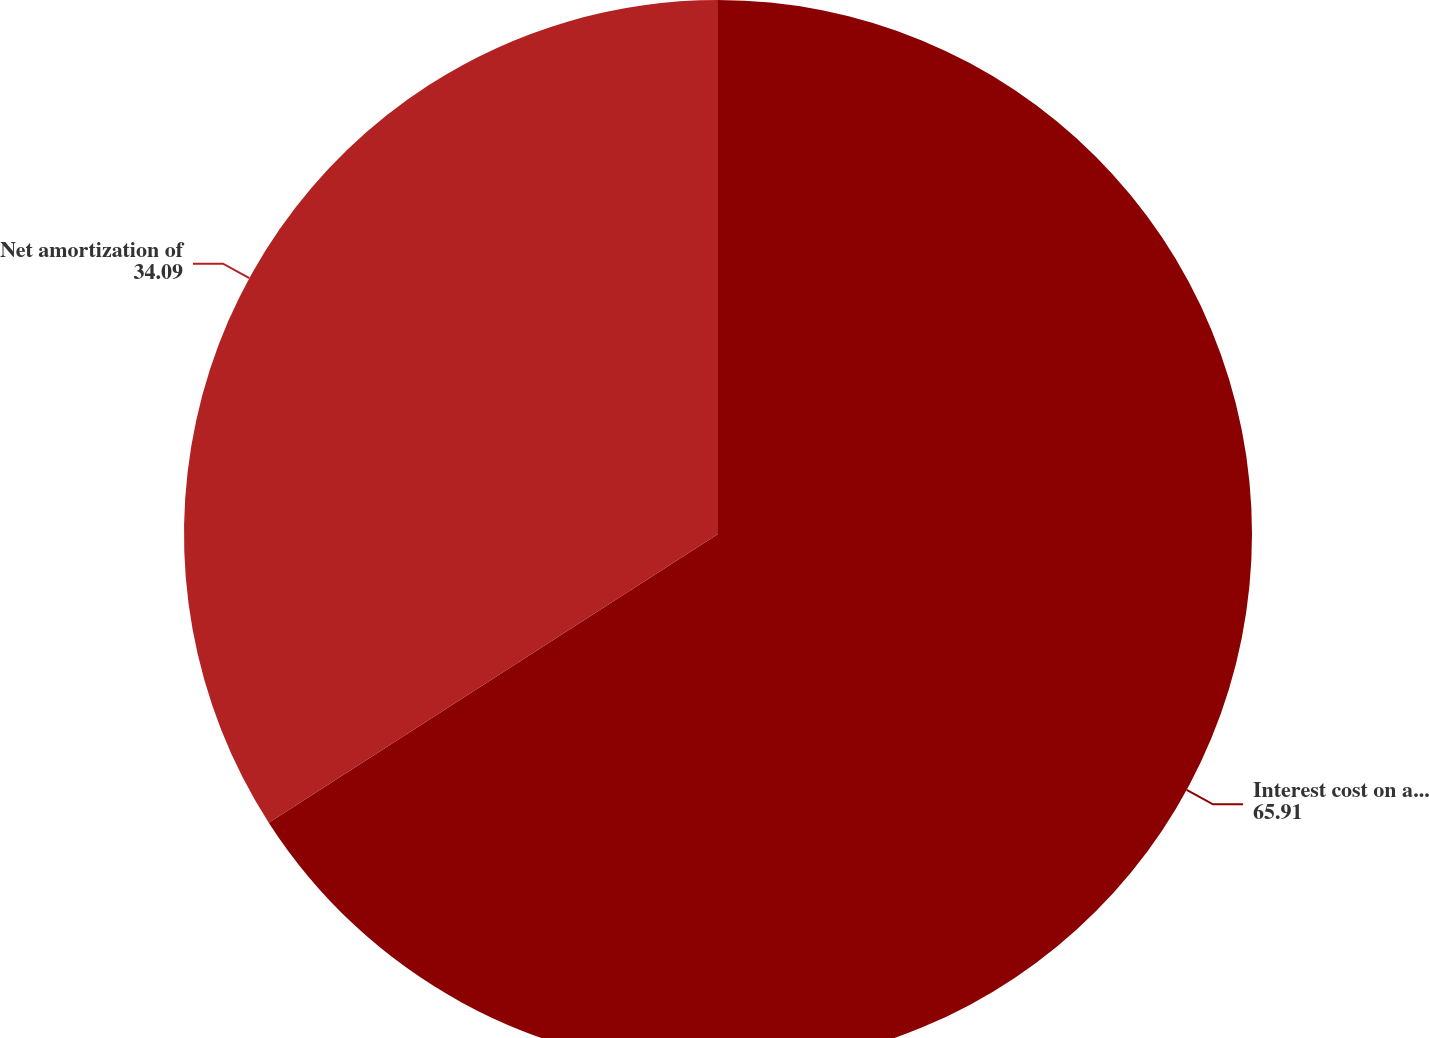Convert chart to OTSL. <chart><loc_0><loc_0><loc_500><loc_500><pie_chart><fcel>Interest cost on accumulated<fcel>Net amortization of<nl><fcel>65.91%<fcel>34.09%<nl></chart> 